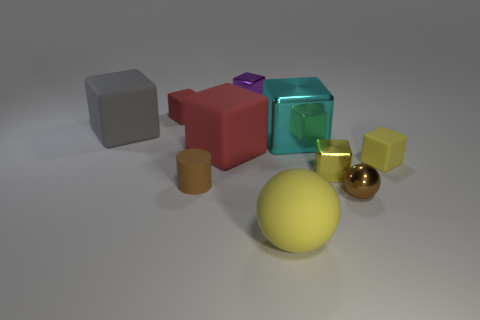Subtract 4 blocks. How many blocks are left? 3 Subtract all cyan cubes. How many cubes are left? 6 Subtract all large red rubber blocks. How many blocks are left? 6 Subtract all blue balls. Subtract all red blocks. How many balls are left? 2 Subtract all blocks. How many objects are left? 3 Subtract all small yellow metal objects. Subtract all red rubber cubes. How many objects are left? 7 Add 1 gray objects. How many gray objects are left? 2 Add 4 big red spheres. How many big red spheres exist? 4 Subtract 0 cyan cylinders. How many objects are left? 10 